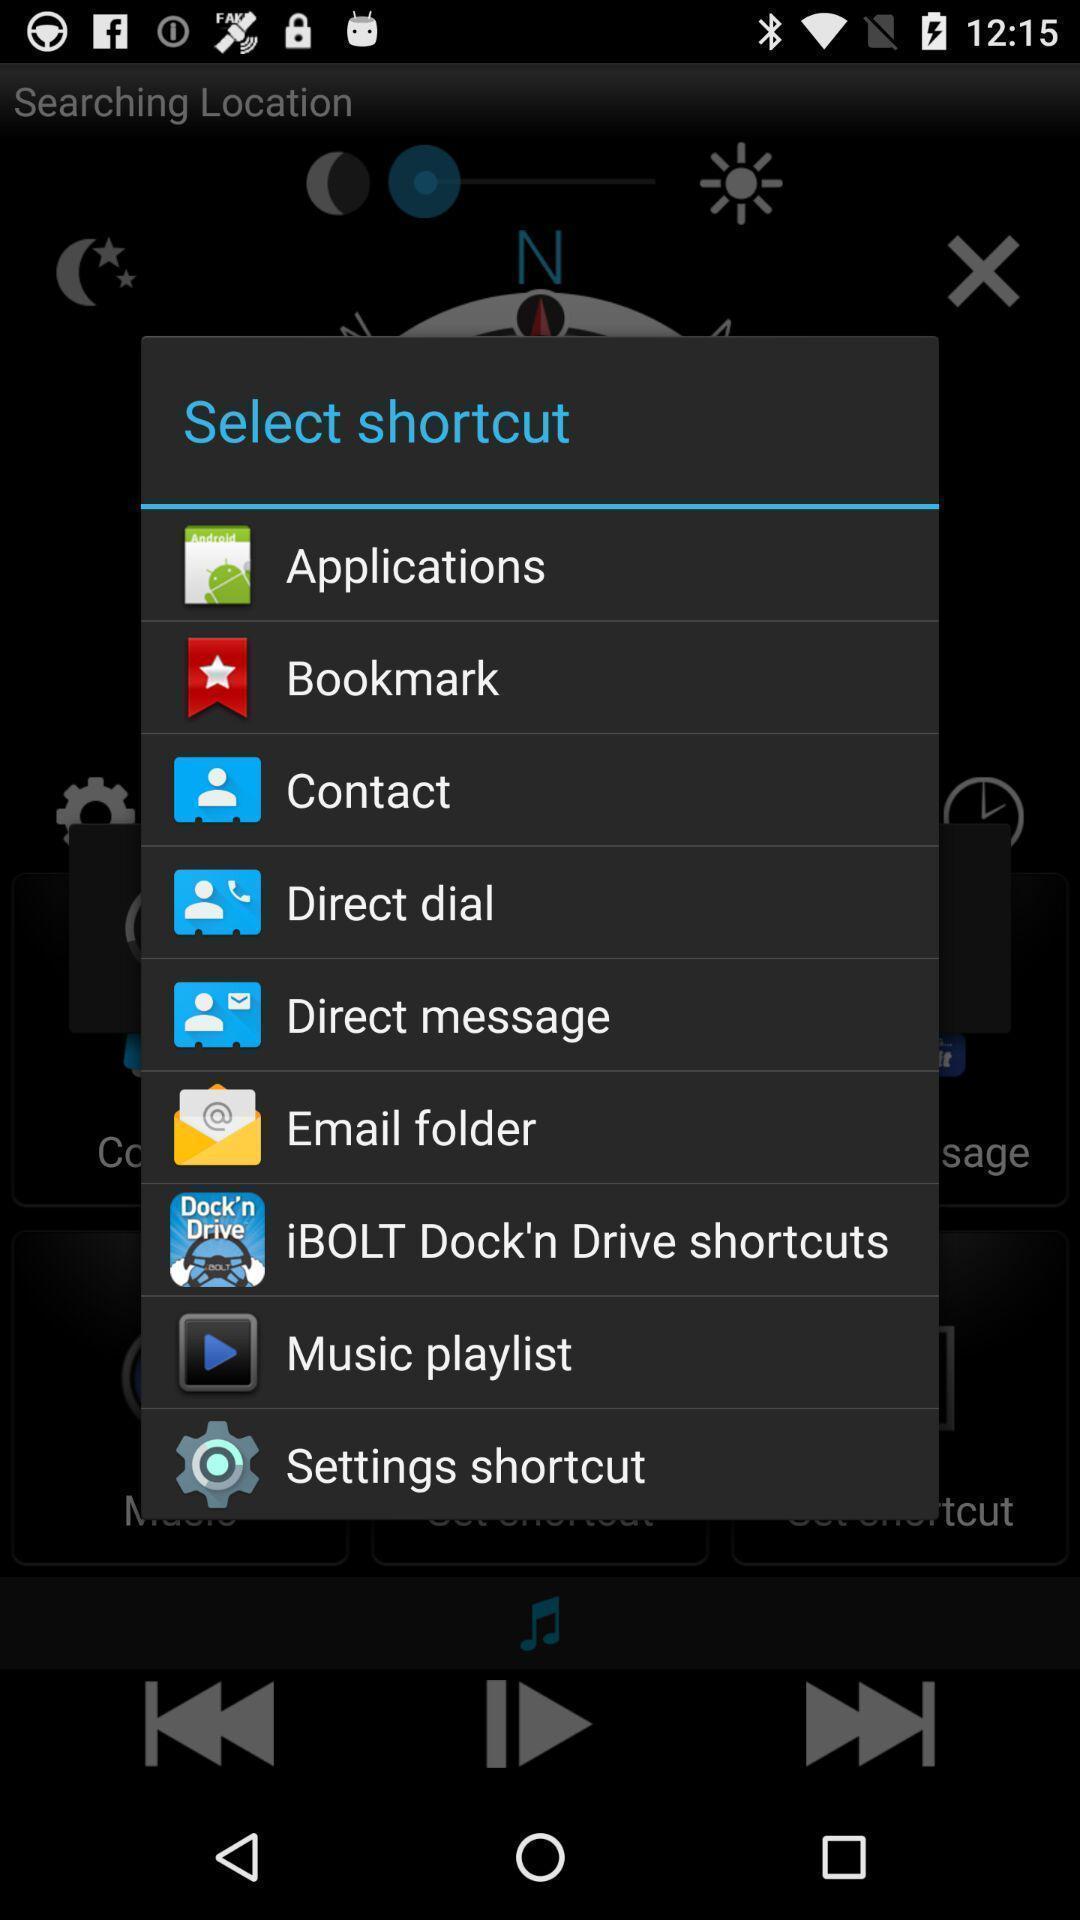What can you discern from this picture? Pop up showing multiple options to select shortcut. 